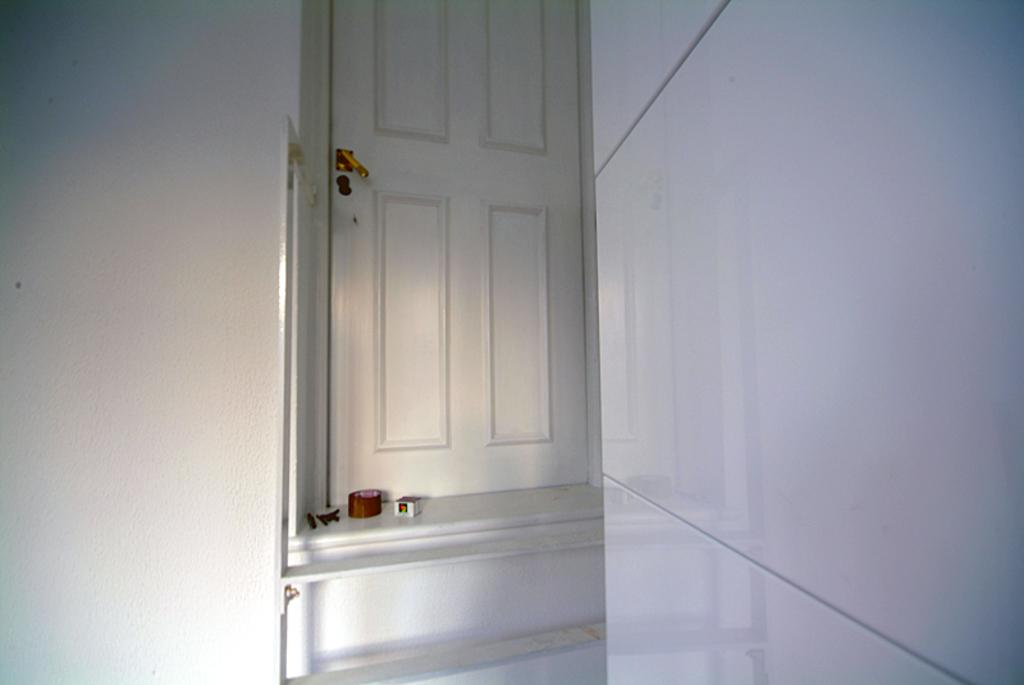What type of structure can be seen in the image? There is a wall in the image. What feature is present in the wall? There is a door in the image. What color is the door? The door is white in color. What is blocking the door in the image? There are objects in front of the door. What type of jeans is hanging on the curtain in the image? There is no curtain or jeans present in the image. 